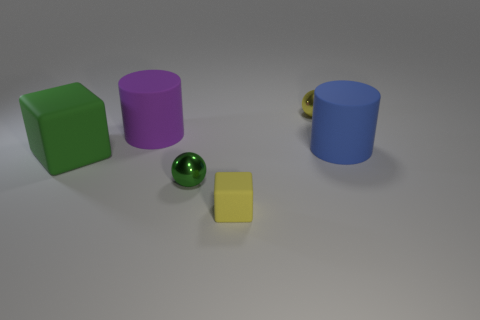Is there any other thing that is the same shape as the small green object?
Your response must be concise. Yes. Is the number of tiny yellow spheres less than the number of big matte things?
Your answer should be compact. Yes. The tiny ball that is in front of the metal sphere behind the large blue rubber cylinder is what color?
Give a very brief answer. Green. What is the material of the small sphere on the left side of the matte block in front of the matte block that is behind the tiny yellow matte thing?
Make the answer very short. Metal. Do the yellow rubber object that is to the right of the purple matte cylinder and the tiny yellow sphere have the same size?
Offer a terse response. Yes. There is a tiny ball in front of the yellow shiny object; what is it made of?
Give a very brief answer. Metal. Are there more green metal cylinders than large green blocks?
Your answer should be compact. No. What number of things are cylinders behind the large blue cylinder or large purple rubber things?
Your answer should be compact. 1. There is a small yellow metal thing on the right side of the purple rubber cylinder; what number of balls are in front of it?
Provide a short and direct response. 1. There is a ball that is behind the tiny metal sphere that is to the left of the tiny metal thing behind the big matte cube; how big is it?
Your answer should be compact. Small. 